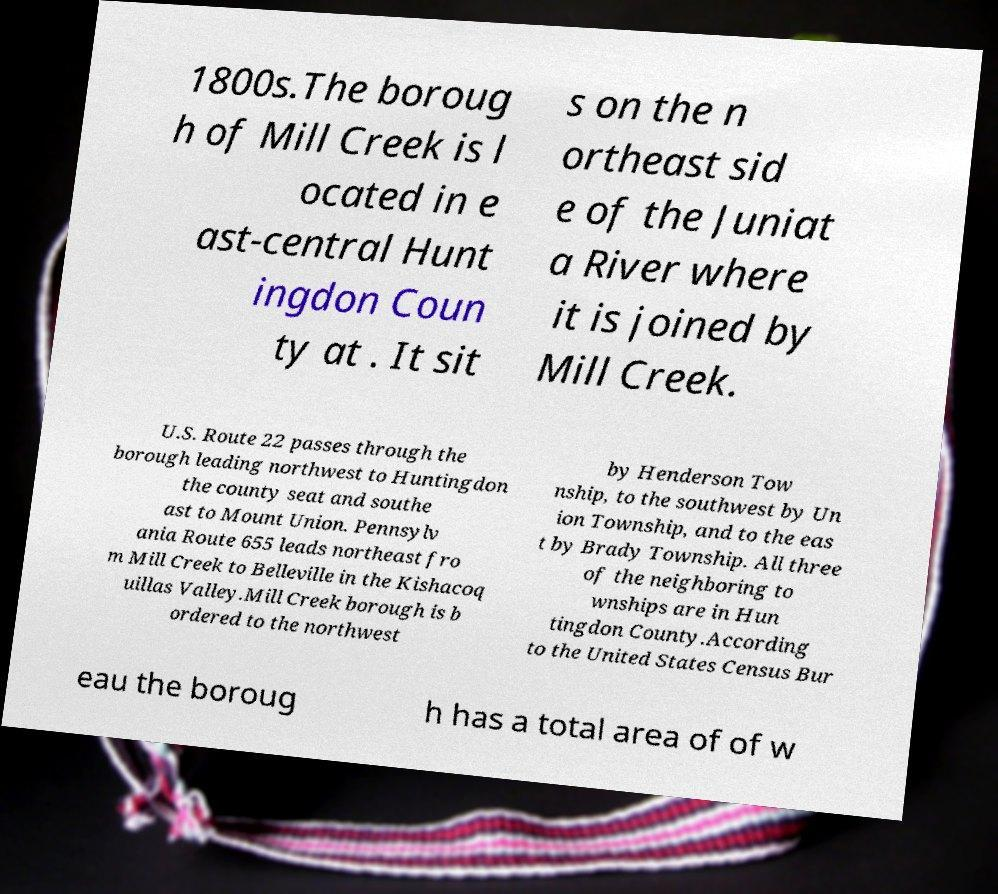Can you accurately transcribe the text from the provided image for me? 1800s.The boroug h of Mill Creek is l ocated in e ast-central Hunt ingdon Coun ty at . It sit s on the n ortheast sid e of the Juniat a River where it is joined by Mill Creek. U.S. Route 22 passes through the borough leading northwest to Huntingdon the county seat and southe ast to Mount Union. Pennsylv ania Route 655 leads northeast fro m Mill Creek to Belleville in the Kishacoq uillas Valley.Mill Creek borough is b ordered to the northwest by Henderson Tow nship, to the southwest by Un ion Township, and to the eas t by Brady Township. All three of the neighboring to wnships are in Hun tingdon County.According to the United States Census Bur eau the boroug h has a total area of of w 